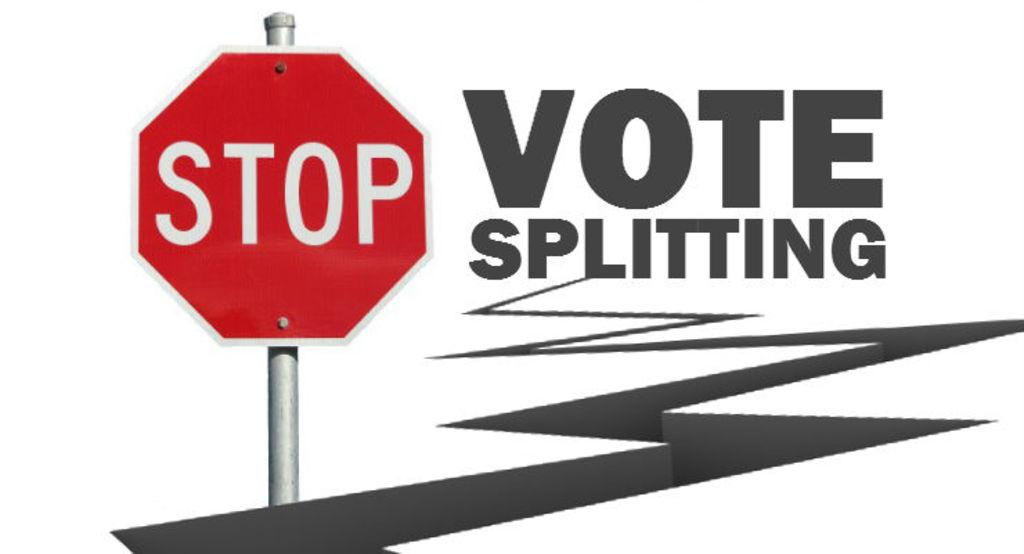<image>
Write a terse but informative summary of the picture. A stop sign is on a poster with the message to stop vote splitting on it. 